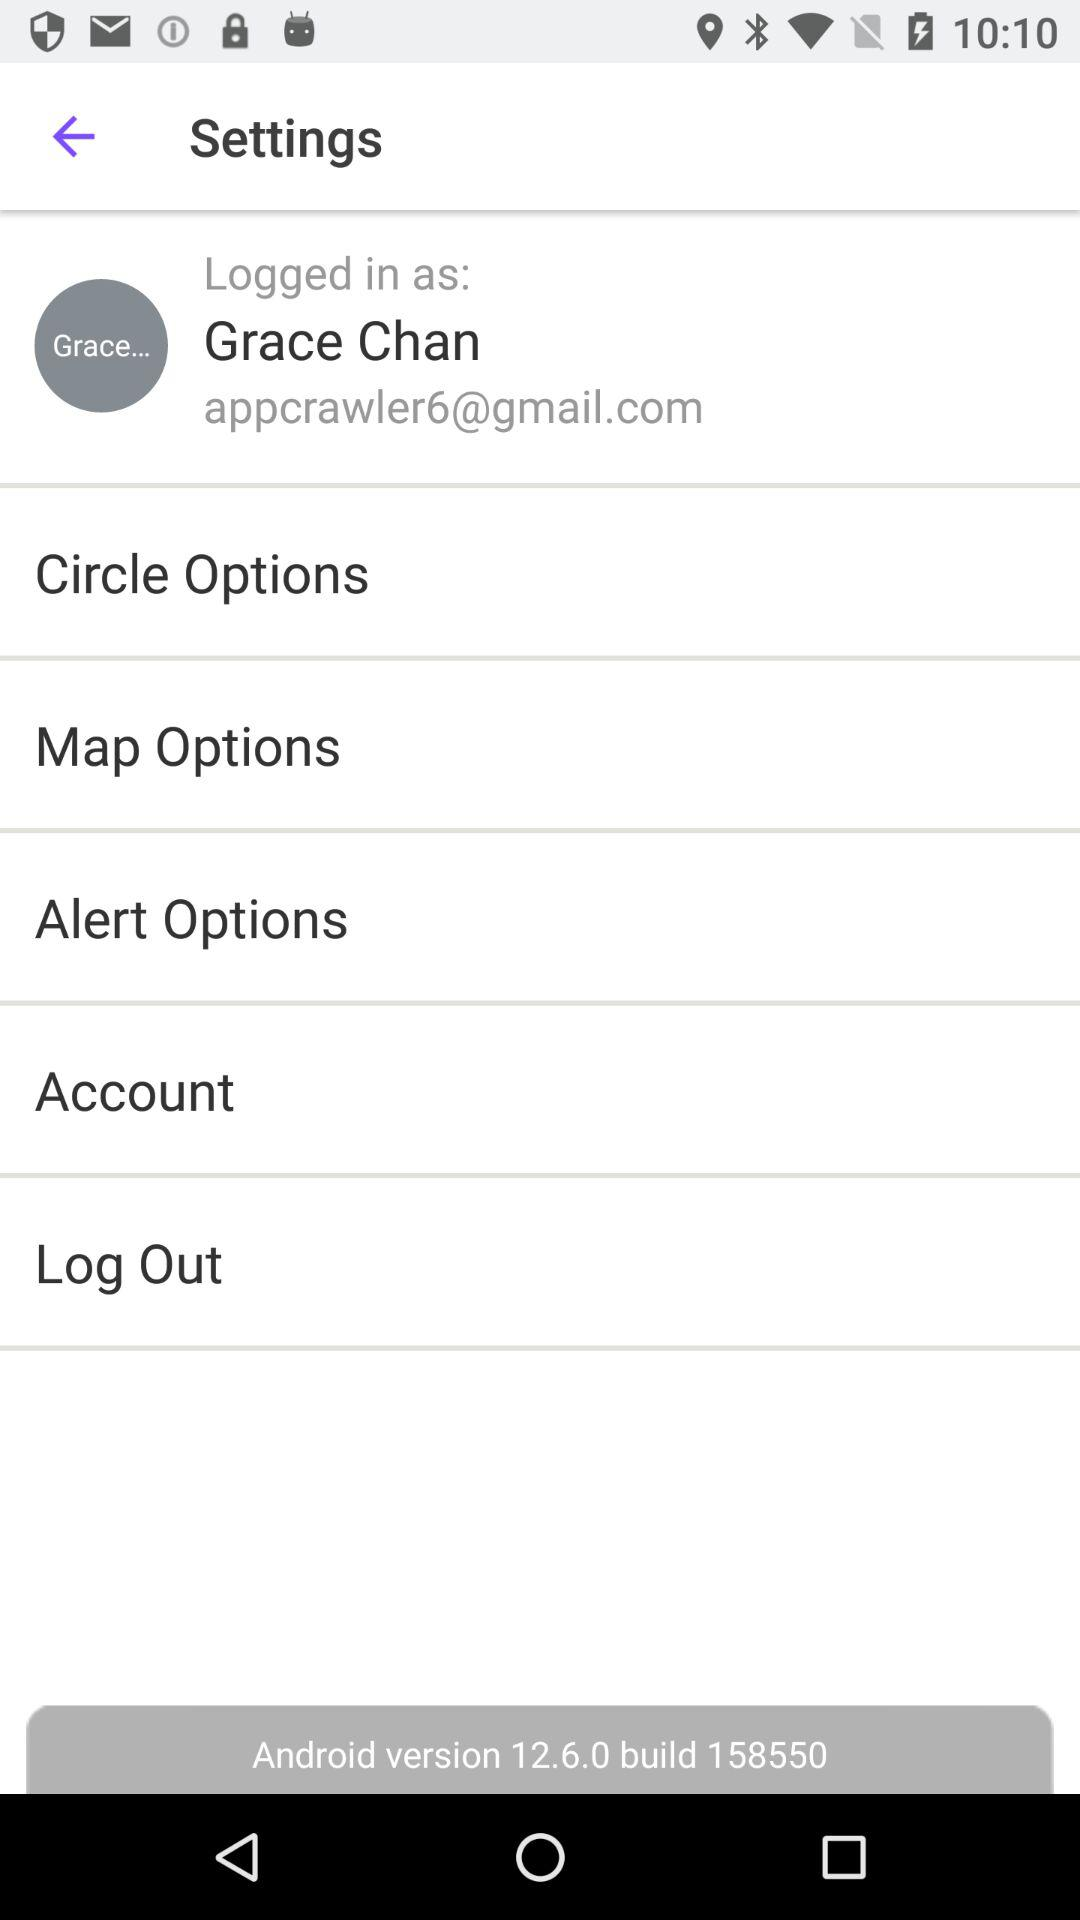What is the email address? The email address is appcrawler6@gmail.com. 